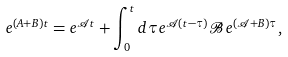Convert formula to latex. <formula><loc_0><loc_0><loc_500><loc_500>e ^ { { \mathcal { ( } A + B ) } t } = e ^ { { \mathcal { A } } t } + \int _ { 0 } ^ { t } d \tau e ^ { { \mathcal { A } } ( t - \tau ) } { \mathcal { B } } e ^ { ( { \mathcal { A } + B } ) \tau } ,</formula> 